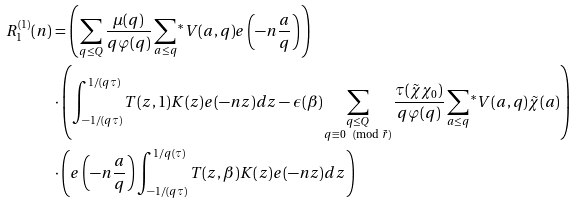<formula> <loc_0><loc_0><loc_500><loc_500>R _ { 1 } ^ { ( 1 ) } ( n ) & = \left ( \sum _ { q \leq Q } \frac { \mu ( q ) } { q \varphi ( q ) } \sum _ { a \leq q } { ^ { * } } V ( a , q ) e \left ( - n \frac { a } { q } \right ) \right ) \\ & \cdot \left ( \int _ { - 1 / ( q \tau ) } ^ { 1 / ( q \tau ) } T ( z , 1 ) K ( z ) e ( - n z ) d z - \epsilon ( \beta ) \sum _ { \substack { q \leq Q \\ q \equiv 0 \pmod { \tilde { r } } } } \frac { \tau ( \tilde { \chi } \chi _ { 0 } ) } { q \varphi ( q ) } \sum _ { a \leq q } { ^ { * } } V ( a , q ) \tilde { \chi } ( a ) \right ) \\ & \cdot \left ( e \left ( - n \frac { a } { q } \right ) \int _ { - 1 / ( q \tau ) } ^ { 1 / q ( \tau ) } T ( z , \beta ) K ( z ) e ( - n z ) d z \right )</formula> 